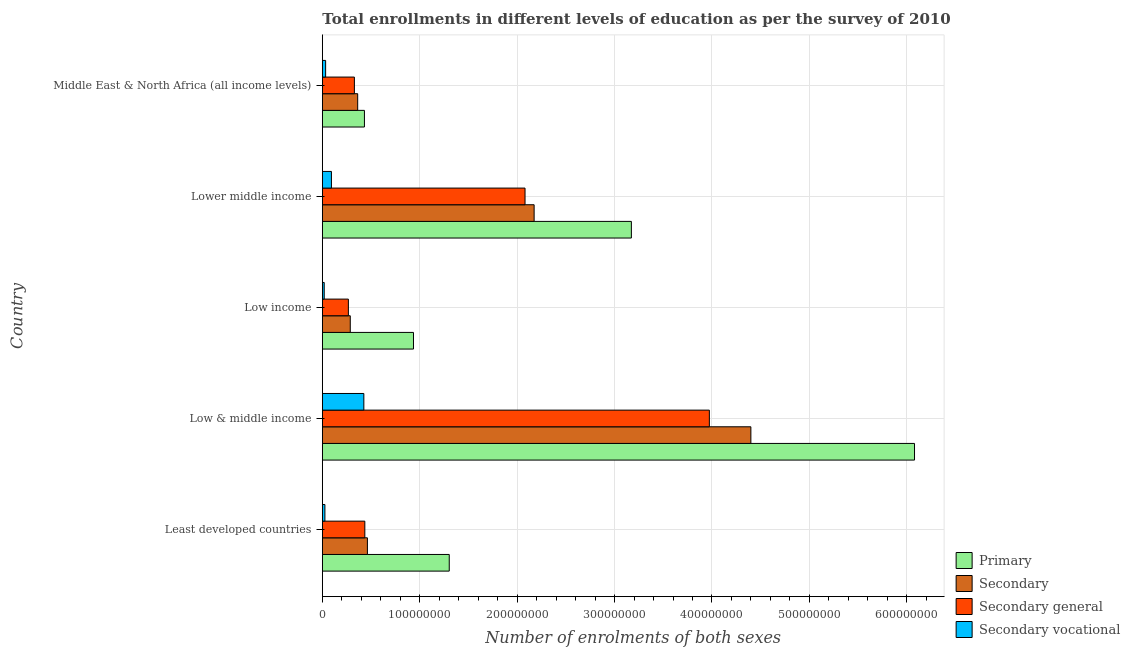Are the number of bars per tick equal to the number of legend labels?
Give a very brief answer. Yes. What is the label of the 5th group of bars from the top?
Make the answer very short. Least developed countries. In how many cases, is the number of bars for a given country not equal to the number of legend labels?
Ensure brevity in your answer.  0. What is the number of enrolments in secondary general education in Low & middle income?
Offer a very short reply. 3.97e+08. Across all countries, what is the maximum number of enrolments in secondary general education?
Provide a succinct answer. 3.97e+08. Across all countries, what is the minimum number of enrolments in primary education?
Offer a terse response. 4.32e+07. In which country was the number of enrolments in primary education minimum?
Your answer should be very brief. Middle East & North Africa (all income levels). What is the total number of enrolments in primary education in the graph?
Make the answer very short. 1.19e+09. What is the difference between the number of enrolments in secondary general education in Low income and that in Lower middle income?
Offer a very short reply. -1.81e+08. What is the difference between the number of enrolments in secondary vocational education in Low & middle income and the number of enrolments in primary education in Least developed countries?
Offer a very short reply. -8.77e+07. What is the average number of enrolments in secondary education per country?
Provide a succinct answer. 1.54e+08. What is the difference between the number of enrolments in secondary general education and number of enrolments in secondary education in Lower middle income?
Your answer should be compact. -9.35e+06. In how many countries, is the number of enrolments in secondary general education greater than 180000000 ?
Make the answer very short. 2. What is the ratio of the number of enrolments in secondary general education in Low & middle income to that in Low income?
Give a very brief answer. 14.86. Is the number of enrolments in secondary general education in Lower middle income less than that in Middle East & North Africa (all income levels)?
Make the answer very short. No. What is the difference between the highest and the second highest number of enrolments in secondary vocational education?
Make the answer very short. 3.33e+07. What is the difference between the highest and the lowest number of enrolments in secondary vocational education?
Provide a short and direct response. 4.07e+07. Is the sum of the number of enrolments in secondary vocational education in Least developed countries and Lower middle income greater than the maximum number of enrolments in secondary general education across all countries?
Give a very brief answer. No. Is it the case that in every country, the sum of the number of enrolments in secondary general education and number of enrolments in primary education is greater than the sum of number of enrolments in secondary education and number of enrolments in secondary vocational education?
Keep it short and to the point. No. What does the 4th bar from the top in Least developed countries represents?
Your answer should be very brief. Primary. What does the 2nd bar from the bottom in Low & middle income represents?
Your answer should be very brief. Secondary. How many bars are there?
Make the answer very short. 20. How many countries are there in the graph?
Offer a terse response. 5. What is the difference between two consecutive major ticks on the X-axis?
Offer a very short reply. 1.00e+08. Does the graph contain grids?
Offer a terse response. Yes. Where does the legend appear in the graph?
Make the answer very short. Bottom right. How are the legend labels stacked?
Your response must be concise. Vertical. What is the title of the graph?
Give a very brief answer. Total enrollments in different levels of education as per the survey of 2010. Does "Fourth 20% of population" appear as one of the legend labels in the graph?
Keep it short and to the point. No. What is the label or title of the X-axis?
Provide a succinct answer. Number of enrolments of both sexes. What is the Number of enrolments of both sexes in Primary in Least developed countries?
Ensure brevity in your answer.  1.30e+08. What is the Number of enrolments of both sexes in Secondary in Least developed countries?
Provide a short and direct response. 4.63e+07. What is the Number of enrolments of both sexes of Secondary general in Least developed countries?
Give a very brief answer. 4.36e+07. What is the Number of enrolments of both sexes in Secondary vocational in Least developed countries?
Provide a short and direct response. 2.65e+06. What is the Number of enrolments of both sexes in Primary in Low & middle income?
Your answer should be very brief. 6.08e+08. What is the Number of enrolments of both sexes of Secondary in Low & middle income?
Offer a very short reply. 4.40e+08. What is the Number of enrolments of both sexes of Secondary general in Low & middle income?
Give a very brief answer. 3.97e+08. What is the Number of enrolments of both sexes in Secondary vocational in Low & middle income?
Your response must be concise. 4.26e+07. What is the Number of enrolments of both sexes of Primary in Low income?
Your response must be concise. 9.36e+07. What is the Number of enrolments of both sexes of Secondary in Low income?
Provide a short and direct response. 2.87e+07. What is the Number of enrolments of both sexes of Secondary general in Low income?
Your answer should be compact. 2.67e+07. What is the Number of enrolments of both sexes in Secondary vocational in Low income?
Your answer should be very brief. 1.94e+06. What is the Number of enrolments of both sexes of Primary in Lower middle income?
Offer a very short reply. 3.17e+08. What is the Number of enrolments of both sexes in Secondary in Lower middle income?
Your response must be concise. 2.17e+08. What is the Number of enrolments of both sexes of Secondary general in Lower middle income?
Your answer should be very brief. 2.08e+08. What is the Number of enrolments of both sexes in Secondary vocational in Lower middle income?
Give a very brief answer. 9.35e+06. What is the Number of enrolments of both sexes of Primary in Middle East & North Africa (all income levels)?
Keep it short and to the point. 4.32e+07. What is the Number of enrolments of both sexes of Secondary in Middle East & North Africa (all income levels)?
Your answer should be very brief. 3.63e+07. What is the Number of enrolments of both sexes in Secondary general in Middle East & North Africa (all income levels)?
Your answer should be very brief. 3.29e+07. What is the Number of enrolments of both sexes in Secondary vocational in Middle East & North Africa (all income levels)?
Offer a terse response. 3.39e+06. Across all countries, what is the maximum Number of enrolments of both sexes in Primary?
Make the answer very short. 6.08e+08. Across all countries, what is the maximum Number of enrolments of both sexes in Secondary?
Your answer should be very brief. 4.40e+08. Across all countries, what is the maximum Number of enrolments of both sexes of Secondary general?
Provide a short and direct response. 3.97e+08. Across all countries, what is the maximum Number of enrolments of both sexes in Secondary vocational?
Your answer should be compact. 4.26e+07. Across all countries, what is the minimum Number of enrolments of both sexes in Primary?
Give a very brief answer. 4.32e+07. Across all countries, what is the minimum Number of enrolments of both sexes in Secondary?
Offer a very short reply. 2.87e+07. Across all countries, what is the minimum Number of enrolments of both sexes of Secondary general?
Make the answer very short. 2.67e+07. Across all countries, what is the minimum Number of enrolments of both sexes in Secondary vocational?
Offer a very short reply. 1.94e+06. What is the total Number of enrolments of both sexes in Primary in the graph?
Offer a terse response. 1.19e+09. What is the total Number of enrolments of both sexes in Secondary in the graph?
Give a very brief answer. 7.69e+08. What is the total Number of enrolments of both sexes of Secondary general in the graph?
Your response must be concise. 7.09e+08. What is the total Number of enrolments of both sexes in Secondary vocational in the graph?
Your answer should be very brief. 5.99e+07. What is the difference between the Number of enrolments of both sexes in Primary in Least developed countries and that in Low & middle income?
Provide a short and direct response. -4.78e+08. What is the difference between the Number of enrolments of both sexes of Secondary in Least developed countries and that in Low & middle income?
Provide a succinct answer. -3.94e+08. What is the difference between the Number of enrolments of both sexes in Secondary general in Least developed countries and that in Low & middle income?
Give a very brief answer. -3.54e+08. What is the difference between the Number of enrolments of both sexes of Secondary vocational in Least developed countries and that in Low & middle income?
Keep it short and to the point. -4.00e+07. What is the difference between the Number of enrolments of both sexes of Primary in Least developed countries and that in Low income?
Keep it short and to the point. 3.67e+07. What is the difference between the Number of enrolments of both sexes in Secondary in Least developed countries and that in Low income?
Your answer should be very brief. 1.76e+07. What is the difference between the Number of enrolments of both sexes of Secondary general in Least developed countries and that in Low income?
Provide a succinct answer. 1.69e+07. What is the difference between the Number of enrolments of both sexes in Secondary vocational in Least developed countries and that in Low income?
Offer a terse response. 7.09e+05. What is the difference between the Number of enrolments of both sexes of Primary in Least developed countries and that in Lower middle income?
Ensure brevity in your answer.  -1.87e+08. What is the difference between the Number of enrolments of both sexes of Secondary in Least developed countries and that in Lower middle income?
Give a very brief answer. -1.71e+08. What is the difference between the Number of enrolments of both sexes of Secondary general in Least developed countries and that in Lower middle income?
Offer a terse response. -1.64e+08. What is the difference between the Number of enrolments of both sexes in Secondary vocational in Least developed countries and that in Lower middle income?
Keep it short and to the point. -6.69e+06. What is the difference between the Number of enrolments of both sexes in Primary in Least developed countries and that in Middle East & North Africa (all income levels)?
Give a very brief answer. 8.71e+07. What is the difference between the Number of enrolments of both sexes of Secondary in Least developed countries and that in Middle East & North Africa (all income levels)?
Your response must be concise. 9.99e+06. What is the difference between the Number of enrolments of both sexes of Secondary general in Least developed countries and that in Middle East & North Africa (all income levels)?
Provide a succinct answer. 1.07e+07. What is the difference between the Number of enrolments of both sexes of Secondary vocational in Least developed countries and that in Middle East & North Africa (all income levels)?
Make the answer very short. -7.37e+05. What is the difference between the Number of enrolments of both sexes in Primary in Low & middle income and that in Low income?
Offer a terse response. 5.14e+08. What is the difference between the Number of enrolments of both sexes of Secondary in Low & middle income and that in Low income?
Your response must be concise. 4.11e+08. What is the difference between the Number of enrolments of both sexes in Secondary general in Low & middle income and that in Low income?
Offer a terse response. 3.71e+08. What is the difference between the Number of enrolments of both sexes of Secondary vocational in Low & middle income and that in Low income?
Give a very brief answer. 4.07e+07. What is the difference between the Number of enrolments of both sexes in Primary in Low & middle income and that in Lower middle income?
Provide a succinct answer. 2.91e+08. What is the difference between the Number of enrolments of both sexes of Secondary in Low & middle income and that in Lower middle income?
Offer a very short reply. 2.22e+08. What is the difference between the Number of enrolments of both sexes in Secondary general in Low & middle income and that in Lower middle income?
Keep it short and to the point. 1.89e+08. What is the difference between the Number of enrolments of both sexes of Secondary vocational in Low & middle income and that in Lower middle income?
Offer a very short reply. 3.33e+07. What is the difference between the Number of enrolments of both sexes in Primary in Low & middle income and that in Middle East & North Africa (all income levels)?
Your answer should be very brief. 5.65e+08. What is the difference between the Number of enrolments of both sexes of Secondary in Low & middle income and that in Middle East & North Africa (all income levels)?
Give a very brief answer. 4.04e+08. What is the difference between the Number of enrolments of both sexes of Secondary general in Low & middle income and that in Middle East & North Africa (all income levels)?
Your answer should be very brief. 3.64e+08. What is the difference between the Number of enrolments of both sexes of Secondary vocational in Low & middle income and that in Middle East & North Africa (all income levels)?
Offer a terse response. 3.92e+07. What is the difference between the Number of enrolments of both sexes of Primary in Low income and that in Lower middle income?
Provide a succinct answer. -2.24e+08. What is the difference between the Number of enrolments of both sexes of Secondary in Low income and that in Lower middle income?
Make the answer very short. -1.89e+08. What is the difference between the Number of enrolments of both sexes of Secondary general in Low income and that in Lower middle income?
Your answer should be very brief. -1.81e+08. What is the difference between the Number of enrolments of both sexes of Secondary vocational in Low income and that in Lower middle income?
Your response must be concise. -7.40e+06. What is the difference between the Number of enrolments of both sexes of Primary in Low income and that in Middle East & North Africa (all income levels)?
Offer a terse response. 5.04e+07. What is the difference between the Number of enrolments of both sexes of Secondary in Low income and that in Middle East & North Africa (all income levels)?
Provide a short and direct response. -7.61e+06. What is the difference between the Number of enrolments of both sexes in Secondary general in Low income and that in Middle East & North Africa (all income levels)?
Keep it short and to the point. -6.16e+06. What is the difference between the Number of enrolments of both sexes in Secondary vocational in Low income and that in Middle East & North Africa (all income levels)?
Give a very brief answer. -1.45e+06. What is the difference between the Number of enrolments of both sexes of Primary in Lower middle income and that in Middle East & North Africa (all income levels)?
Provide a short and direct response. 2.74e+08. What is the difference between the Number of enrolments of both sexes in Secondary in Lower middle income and that in Middle East & North Africa (all income levels)?
Make the answer very short. 1.81e+08. What is the difference between the Number of enrolments of both sexes of Secondary general in Lower middle income and that in Middle East & North Africa (all income levels)?
Offer a terse response. 1.75e+08. What is the difference between the Number of enrolments of both sexes of Secondary vocational in Lower middle income and that in Middle East & North Africa (all income levels)?
Keep it short and to the point. 5.96e+06. What is the difference between the Number of enrolments of both sexes in Primary in Least developed countries and the Number of enrolments of both sexes in Secondary in Low & middle income?
Offer a very short reply. -3.10e+08. What is the difference between the Number of enrolments of both sexes of Primary in Least developed countries and the Number of enrolments of both sexes of Secondary general in Low & middle income?
Make the answer very short. -2.67e+08. What is the difference between the Number of enrolments of both sexes of Primary in Least developed countries and the Number of enrolments of both sexes of Secondary vocational in Low & middle income?
Your response must be concise. 8.77e+07. What is the difference between the Number of enrolments of both sexes of Secondary in Least developed countries and the Number of enrolments of both sexes of Secondary general in Low & middle income?
Keep it short and to the point. -3.51e+08. What is the difference between the Number of enrolments of both sexes of Secondary in Least developed countries and the Number of enrolments of both sexes of Secondary vocational in Low & middle income?
Provide a succinct answer. 3.66e+06. What is the difference between the Number of enrolments of both sexes in Secondary general in Least developed countries and the Number of enrolments of both sexes in Secondary vocational in Low & middle income?
Provide a succinct answer. 1.01e+06. What is the difference between the Number of enrolments of both sexes of Primary in Least developed countries and the Number of enrolments of both sexes of Secondary in Low income?
Ensure brevity in your answer.  1.02e+08. What is the difference between the Number of enrolments of both sexes in Primary in Least developed countries and the Number of enrolments of both sexes in Secondary general in Low income?
Your response must be concise. 1.04e+08. What is the difference between the Number of enrolments of both sexes in Primary in Least developed countries and the Number of enrolments of both sexes in Secondary vocational in Low income?
Ensure brevity in your answer.  1.28e+08. What is the difference between the Number of enrolments of both sexes in Secondary in Least developed countries and the Number of enrolments of both sexes in Secondary general in Low income?
Your answer should be compact. 1.95e+07. What is the difference between the Number of enrolments of both sexes in Secondary in Least developed countries and the Number of enrolments of both sexes in Secondary vocational in Low income?
Your answer should be compact. 4.43e+07. What is the difference between the Number of enrolments of both sexes in Secondary general in Least developed countries and the Number of enrolments of both sexes in Secondary vocational in Low income?
Ensure brevity in your answer.  4.17e+07. What is the difference between the Number of enrolments of both sexes of Primary in Least developed countries and the Number of enrolments of both sexes of Secondary in Lower middle income?
Your answer should be very brief. -8.71e+07. What is the difference between the Number of enrolments of both sexes in Primary in Least developed countries and the Number of enrolments of both sexes in Secondary general in Lower middle income?
Offer a very short reply. -7.78e+07. What is the difference between the Number of enrolments of both sexes of Primary in Least developed countries and the Number of enrolments of both sexes of Secondary vocational in Lower middle income?
Ensure brevity in your answer.  1.21e+08. What is the difference between the Number of enrolments of both sexes in Secondary in Least developed countries and the Number of enrolments of both sexes in Secondary general in Lower middle income?
Your answer should be very brief. -1.62e+08. What is the difference between the Number of enrolments of both sexes of Secondary in Least developed countries and the Number of enrolments of both sexes of Secondary vocational in Lower middle income?
Offer a very short reply. 3.69e+07. What is the difference between the Number of enrolments of both sexes of Secondary general in Least developed countries and the Number of enrolments of both sexes of Secondary vocational in Lower middle income?
Offer a terse response. 3.43e+07. What is the difference between the Number of enrolments of both sexes of Primary in Least developed countries and the Number of enrolments of both sexes of Secondary in Middle East & North Africa (all income levels)?
Your response must be concise. 9.40e+07. What is the difference between the Number of enrolments of both sexes in Primary in Least developed countries and the Number of enrolments of both sexes in Secondary general in Middle East & North Africa (all income levels)?
Your response must be concise. 9.74e+07. What is the difference between the Number of enrolments of both sexes in Primary in Least developed countries and the Number of enrolments of both sexes in Secondary vocational in Middle East & North Africa (all income levels)?
Your response must be concise. 1.27e+08. What is the difference between the Number of enrolments of both sexes of Secondary in Least developed countries and the Number of enrolments of both sexes of Secondary general in Middle East & North Africa (all income levels)?
Make the answer very short. 1.34e+07. What is the difference between the Number of enrolments of both sexes in Secondary in Least developed countries and the Number of enrolments of both sexes in Secondary vocational in Middle East & North Africa (all income levels)?
Your answer should be very brief. 4.29e+07. What is the difference between the Number of enrolments of both sexes of Secondary general in Least developed countries and the Number of enrolments of both sexes of Secondary vocational in Middle East & North Africa (all income levels)?
Provide a short and direct response. 4.02e+07. What is the difference between the Number of enrolments of both sexes of Primary in Low & middle income and the Number of enrolments of both sexes of Secondary in Low income?
Offer a terse response. 5.79e+08. What is the difference between the Number of enrolments of both sexes in Primary in Low & middle income and the Number of enrolments of both sexes in Secondary general in Low income?
Make the answer very short. 5.81e+08. What is the difference between the Number of enrolments of both sexes of Primary in Low & middle income and the Number of enrolments of both sexes of Secondary vocational in Low income?
Keep it short and to the point. 6.06e+08. What is the difference between the Number of enrolments of both sexes of Secondary in Low & middle income and the Number of enrolments of both sexes of Secondary general in Low income?
Offer a very short reply. 4.13e+08. What is the difference between the Number of enrolments of both sexes of Secondary in Low & middle income and the Number of enrolments of both sexes of Secondary vocational in Low income?
Provide a succinct answer. 4.38e+08. What is the difference between the Number of enrolments of both sexes of Secondary general in Low & middle income and the Number of enrolments of both sexes of Secondary vocational in Low income?
Your answer should be compact. 3.95e+08. What is the difference between the Number of enrolments of both sexes in Primary in Low & middle income and the Number of enrolments of both sexes in Secondary in Lower middle income?
Provide a short and direct response. 3.90e+08. What is the difference between the Number of enrolments of both sexes of Primary in Low & middle income and the Number of enrolments of both sexes of Secondary general in Lower middle income?
Your answer should be very brief. 4.00e+08. What is the difference between the Number of enrolments of both sexes in Primary in Low & middle income and the Number of enrolments of both sexes in Secondary vocational in Lower middle income?
Offer a very short reply. 5.99e+08. What is the difference between the Number of enrolments of both sexes of Secondary in Low & middle income and the Number of enrolments of both sexes of Secondary general in Lower middle income?
Your response must be concise. 2.32e+08. What is the difference between the Number of enrolments of both sexes of Secondary in Low & middle income and the Number of enrolments of both sexes of Secondary vocational in Lower middle income?
Your answer should be very brief. 4.31e+08. What is the difference between the Number of enrolments of both sexes of Secondary general in Low & middle income and the Number of enrolments of both sexes of Secondary vocational in Lower middle income?
Your response must be concise. 3.88e+08. What is the difference between the Number of enrolments of both sexes of Primary in Low & middle income and the Number of enrolments of both sexes of Secondary in Middle East & North Africa (all income levels)?
Provide a succinct answer. 5.72e+08. What is the difference between the Number of enrolments of both sexes in Primary in Low & middle income and the Number of enrolments of both sexes in Secondary general in Middle East & North Africa (all income levels)?
Provide a succinct answer. 5.75e+08. What is the difference between the Number of enrolments of both sexes of Primary in Low & middle income and the Number of enrolments of both sexes of Secondary vocational in Middle East & North Africa (all income levels)?
Offer a terse response. 6.05e+08. What is the difference between the Number of enrolments of both sexes in Secondary in Low & middle income and the Number of enrolments of both sexes in Secondary general in Middle East & North Africa (all income levels)?
Provide a succinct answer. 4.07e+08. What is the difference between the Number of enrolments of both sexes in Secondary in Low & middle income and the Number of enrolments of both sexes in Secondary vocational in Middle East & North Africa (all income levels)?
Ensure brevity in your answer.  4.37e+08. What is the difference between the Number of enrolments of both sexes of Secondary general in Low & middle income and the Number of enrolments of both sexes of Secondary vocational in Middle East & North Africa (all income levels)?
Your answer should be compact. 3.94e+08. What is the difference between the Number of enrolments of both sexes in Primary in Low income and the Number of enrolments of both sexes in Secondary in Lower middle income?
Provide a succinct answer. -1.24e+08. What is the difference between the Number of enrolments of both sexes of Primary in Low income and the Number of enrolments of both sexes of Secondary general in Lower middle income?
Your answer should be very brief. -1.15e+08. What is the difference between the Number of enrolments of both sexes in Primary in Low income and the Number of enrolments of both sexes in Secondary vocational in Lower middle income?
Provide a short and direct response. 8.42e+07. What is the difference between the Number of enrolments of both sexes of Secondary in Low income and the Number of enrolments of both sexes of Secondary general in Lower middle income?
Your answer should be very brief. -1.79e+08. What is the difference between the Number of enrolments of both sexes of Secondary in Low income and the Number of enrolments of both sexes of Secondary vocational in Lower middle income?
Your answer should be compact. 1.93e+07. What is the difference between the Number of enrolments of both sexes of Secondary general in Low income and the Number of enrolments of both sexes of Secondary vocational in Lower middle income?
Make the answer very short. 1.74e+07. What is the difference between the Number of enrolments of both sexes of Primary in Low income and the Number of enrolments of both sexes of Secondary in Middle East & North Africa (all income levels)?
Offer a terse response. 5.73e+07. What is the difference between the Number of enrolments of both sexes of Primary in Low income and the Number of enrolments of both sexes of Secondary general in Middle East & North Africa (all income levels)?
Provide a succinct answer. 6.07e+07. What is the difference between the Number of enrolments of both sexes in Primary in Low income and the Number of enrolments of both sexes in Secondary vocational in Middle East & North Africa (all income levels)?
Provide a succinct answer. 9.02e+07. What is the difference between the Number of enrolments of both sexes of Secondary in Low income and the Number of enrolments of both sexes of Secondary general in Middle East & North Africa (all income levels)?
Offer a very short reply. -4.22e+06. What is the difference between the Number of enrolments of both sexes in Secondary in Low income and the Number of enrolments of both sexes in Secondary vocational in Middle East & North Africa (all income levels)?
Provide a succinct answer. 2.53e+07. What is the difference between the Number of enrolments of both sexes in Secondary general in Low income and the Number of enrolments of both sexes in Secondary vocational in Middle East & North Africa (all income levels)?
Your answer should be compact. 2.34e+07. What is the difference between the Number of enrolments of both sexes of Primary in Lower middle income and the Number of enrolments of both sexes of Secondary in Middle East & North Africa (all income levels)?
Your answer should be compact. 2.81e+08. What is the difference between the Number of enrolments of both sexes of Primary in Lower middle income and the Number of enrolments of both sexes of Secondary general in Middle East & North Africa (all income levels)?
Your response must be concise. 2.84e+08. What is the difference between the Number of enrolments of both sexes of Primary in Lower middle income and the Number of enrolments of both sexes of Secondary vocational in Middle East & North Africa (all income levels)?
Provide a succinct answer. 3.14e+08. What is the difference between the Number of enrolments of both sexes of Secondary in Lower middle income and the Number of enrolments of both sexes of Secondary general in Middle East & North Africa (all income levels)?
Provide a succinct answer. 1.85e+08. What is the difference between the Number of enrolments of both sexes in Secondary in Lower middle income and the Number of enrolments of both sexes in Secondary vocational in Middle East & North Africa (all income levels)?
Provide a short and direct response. 2.14e+08. What is the difference between the Number of enrolments of both sexes of Secondary general in Lower middle income and the Number of enrolments of both sexes of Secondary vocational in Middle East & North Africa (all income levels)?
Keep it short and to the point. 2.05e+08. What is the average Number of enrolments of both sexes in Primary per country?
Your response must be concise. 2.38e+08. What is the average Number of enrolments of both sexes of Secondary per country?
Provide a succinct answer. 1.54e+08. What is the average Number of enrolments of both sexes of Secondary general per country?
Ensure brevity in your answer.  1.42e+08. What is the average Number of enrolments of both sexes of Secondary vocational per country?
Keep it short and to the point. 1.20e+07. What is the difference between the Number of enrolments of both sexes of Primary and Number of enrolments of both sexes of Secondary in Least developed countries?
Offer a terse response. 8.40e+07. What is the difference between the Number of enrolments of both sexes of Primary and Number of enrolments of both sexes of Secondary general in Least developed countries?
Your answer should be compact. 8.67e+07. What is the difference between the Number of enrolments of both sexes in Primary and Number of enrolments of both sexes in Secondary vocational in Least developed countries?
Provide a short and direct response. 1.28e+08. What is the difference between the Number of enrolments of both sexes in Secondary and Number of enrolments of both sexes in Secondary general in Least developed countries?
Offer a very short reply. 2.65e+06. What is the difference between the Number of enrolments of both sexes in Secondary and Number of enrolments of both sexes in Secondary vocational in Least developed countries?
Your response must be concise. 4.36e+07. What is the difference between the Number of enrolments of both sexes of Secondary general and Number of enrolments of both sexes of Secondary vocational in Least developed countries?
Your response must be concise. 4.10e+07. What is the difference between the Number of enrolments of both sexes in Primary and Number of enrolments of both sexes in Secondary in Low & middle income?
Make the answer very short. 1.68e+08. What is the difference between the Number of enrolments of both sexes of Primary and Number of enrolments of both sexes of Secondary general in Low & middle income?
Provide a short and direct response. 2.11e+08. What is the difference between the Number of enrolments of both sexes of Primary and Number of enrolments of both sexes of Secondary vocational in Low & middle income?
Your answer should be compact. 5.65e+08. What is the difference between the Number of enrolments of both sexes in Secondary and Number of enrolments of both sexes in Secondary general in Low & middle income?
Your response must be concise. 4.26e+07. What is the difference between the Number of enrolments of both sexes of Secondary and Number of enrolments of both sexes of Secondary vocational in Low & middle income?
Give a very brief answer. 3.97e+08. What is the difference between the Number of enrolments of both sexes in Secondary general and Number of enrolments of both sexes in Secondary vocational in Low & middle income?
Offer a terse response. 3.55e+08. What is the difference between the Number of enrolments of both sexes of Primary and Number of enrolments of both sexes of Secondary in Low income?
Offer a terse response. 6.49e+07. What is the difference between the Number of enrolments of both sexes in Primary and Number of enrolments of both sexes in Secondary general in Low income?
Your response must be concise. 6.68e+07. What is the difference between the Number of enrolments of both sexes of Primary and Number of enrolments of both sexes of Secondary vocational in Low income?
Provide a succinct answer. 9.16e+07. What is the difference between the Number of enrolments of both sexes of Secondary and Number of enrolments of both sexes of Secondary general in Low income?
Your answer should be very brief. 1.94e+06. What is the difference between the Number of enrolments of both sexes of Secondary and Number of enrolments of both sexes of Secondary vocational in Low income?
Provide a succinct answer. 2.67e+07. What is the difference between the Number of enrolments of both sexes of Secondary general and Number of enrolments of both sexes of Secondary vocational in Low income?
Provide a short and direct response. 2.48e+07. What is the difference between the Number of enrolments of both sexes of Primary and Number of enrolments of both sexes of Secondary in Lower middle income?
Keep it short and to the point. 9.98e+07. What is the difference between the Number of enrolments of both sexes in Primary and Number of enrolments of both sexes in Secondary general in Lower middle income?
Offer a terse response. 1.09e+08. What is the difference between the Number of enrolments of both sexes in Primary and Number of enrolments of both sexes in Secondary vocational in Lower middle income?
Make the answer very short. 3.08e+08. What is the difference between the Number of enrolments of both sexes in Secondary and Number of enrolments of both sexes in Secondary general in Lower middle income?
Offer a very short reply. 9.35e+06. What is the difference between the Number of enrolments of both sexes of Secondary and Number of enrolments of both sexes of Secondary vocational in Lower middle income?
Ensure brevity in your answer.  2.08e+08. What is the difference between the Number of enrolments of both sexes of Secondary general and Number of enrolments of both sexes of Secondary vocational in Lower middle income?
Offer a terse response. 1.99e+08. What is the difference between the Number of enrolments of both sexes in Primary and Number of enrolments of both sexes in Secondary in Middle East & North Africa (all income levels)?
Keep it short and to the point. 6.93e+06. What is the difference between the Number of enrolments of both sexes in Primary and Number of enrolments of both sexes in Secondary general in Middle East & North Africa (all income levels)?
Your response must be concise. 1.03e+07. What is the difference between the Number of enrolments of both sexes of Primary and Number of enrolments of both sexes of Secondary vocational in Middle East & North Africa (all income levels)?
Your answer should be compact. 3.98e+07. What is the difference between the Number of enrolments of both sexes in Secondary and Number of enrolments of both sexes in Secondary general in Middle East & North Africa (all income levels)?
Offer a very short reply. 3.39e+06. What is the difference between the Number of enrolments of both sexes of Secondary and Number of enrolments of both sexes of Secondary vocational in Middle East & North Africa (all income levels)?
Give a very brief answer. 3.29e+07. What is the difference between the Number of enrolments of both sexes in Secondary general and Number of enrolments of both sexes in Secondary vocational in Middle East & North Africa (all income levels)?
Make the answer very short. 2.95e+07. What is the ratio of the Number of enrolments of both sexes in Primary in Least developed countries to that in Low & middle income?
Provide a short and direct response. 0.21. What is the ratio of the Number of enrolments of both sexes in Secondary in Least developed countries to that in Low & middle income?
Your answer should be compact. 0.11. What is the ratio of the Number of enrolments of both sexes of Secondary general in Least developed countries to that in Low & middle income?
Make the answer very short. 0.11. What is the ratio of the Number of enrolments of both sexes in Secondary vocational in Least developed countries to that in Low & middle income?
Ensure brevity in your answer.  0.06. What is the ratio of the Number of enrolments of both sexes of Primary in Least developed countries to that in Low income?
Give a very brief answer. 1.39. What is the ratio of the Number of enrolments of both sexes of Secondary in Least developed countries to that in Low income?
Your answer should be compact. 1.61. What is the ratio of the Number of enrolments of both sexes of Secondary general in Least developed countries to that in Low income?
Provide a succinct answer. 1.63. What is the ratio of the Number of enrolments of both sexes in Secondary vocational in Least developed countries to that in Low income?
Your answer should be very brief. 1.36. What is the ratio of the Number of enrolments of both sexes in Primary in Least developed countries to that in Lower middle income?
Your answer should be compact. 0.41. What is the ratio of the Number of enrolments of both sexes in Secondary in Least developed countries to that in Lower middle income?
Your response must be concise. 0.21. What is the ratio of the Number of enrolments of both sexes of Secondary general in Least developed countries to that in Lower middle income?
Offer a very short reply. 0.21. What is the ratio of the Number of enrolments of both sexes of Secondary vocational in Least developed countries to that in Lower middle income?
Your answer should be compact. 0.28. What is the ratio of the Number of enrolments of both sexes of Primary in Least developed countries to that in Middle East & North Africa (all income levels)?
Offer a terse response. 3.01. What is the ratio of the Number of enrolments of both sexes in Secondary in Least developed countries to that in Middle East & North Africa (all income levels)?
Give a very brief answer. 1.28. What is the ratio of the Number of enrolments of both sexes in Secondary general in Least developed countries to that in Middle East & North Africa (all income levels)?
Your answer should be compact. 1.33. What is the ratio of the Number of enrolments of both sexes in Secondary vocational in Least developed countries to that in Middle East & North Africa (all income levels)?
Offer a terse response. 0.78. What is the ratio of the Number of enrolments of both sexes of Primary in Low & middle income to that in Low income?
Keep it short and to the point. 6.5. What is the ratio of the Number of enrolments of both sexes in Secondary in Low & middle income to that in Low income?
Your answer should be very brief. 15.34. What is the ratio of the Number of enrolments of both sexes in Secondary general in Low & middle income to that in Low income?
Keep it short and to the point. 14.86. What is the ratio of the Number of enrolments of both sexes in Secondary vocational in Low & middle income to that in Low income?
Provide a succinct answer. 21.95. What is the ratio of the Number of enrolments of both sexes of Primary in Low & middle income to that in Lower middle income?
Your answer should be very brief. 1.92. What is the ratio of the Number of enrolments of both sexes in Secondary in Low & middle income to that in Lower middle income?
Your response must be concise. 2.02. What is the ratio of the Number of enrolments of both sexes in Secondary general in Low & middle income to that in Lower middle income?
Offer a terse response. 1.91. What is the ratio of the Number of enrolments of both sexes of Secondary vocational in Low & middle income to that in Lower middle income?
Give a very brief answer. 4.56. What is the ratio of the Number of enrolments of both sexes of Primary in Low & middle income to that in Middle East & North Africa (all income levels)?
Offer a very short reply. 14.07. What is the ratio of the Number of enrolments of both sexes of Secondary in Low & middle income to that in Middle East & North Africa (all income levels)?
Provide a short and direct response. 12.12. What is the ratio of the Number of enrolments of both sexes in Secondary general in Low & middle income to that in Middle East & North Africa (all income levels)?
Give a very brief answer. 12.07. What is the ratio of the Number of enrolments of both sexes of Secondary vocational in Low & middle income to that in Middle East & North Africa (all income levels)?
Provide a succinct answer. 12.58. What is the ratio of the Number of enrolments of both sexes in Primary in Low income to that in Lower middle income?
Ensure brevity in your answer.  0.29. What is the ratio of the Number of enrolments of both sexes in Secondary in Low income to that in Lower middle income?
Provide a short and direct response. 0.13. What is the ratio of the Number of enrolments of both sexes in Secondary general in Low income to that in Lower middle income?
Keep it short and to the point. 0.13. What is the ratio of the Number of enrolments of both sexes in Secondary vocational in Low income to that in Lower middle income?
Make the answer very short. 0.21. What is the ratio of the Number of enrolments of both sexes in Primary in Low income to that in Middle East & North Africa (all income levels)?
Provide a short and direct response. 2.17. What is the ratio of the Number of enrolments of both sexes in Secondary in Low income to that in Middle East & North Africa (all income levels)?
Keep it short and to the point. 0.79. What is the ratio of the Number of enrolments of both sexes of Secondary general in Low income to that in Middle East & North Africa (all income levels)?
Your response must be concise. 0.81. What is the ratio of the Number of enrolments of both sexes of Secondary vocational in Low income to that in Middle East & North Africa (all income levels)?
Your response must be concise. 0.57. What is the ratio of the Number of enrolments of both sexes of Primary in Lower middle income to that in Middle East & North Africa (all income levels)?
Your answer should be very brief. 7.34. What is the ratio of the Number of enrolments of both sexes in Secondary in Lower middle income to that in Middle East & North Africa (all income levels)?
Your answer should be very brief. 5.99. What is the ratio of the Number of enrolments of both sexes of Secondary general in Lower middle income to that in Middle East & North Africa (all income levels)?
Ensure brevity in your answer.  6.32. What is the ratio of the Number of enrolments of both sexes of Secondary vocational in Lower middle income to that in Middle East & North Africa (all income levels)?
Give a very brief answer. 2.76. What is the difference between the highest and the second highest Number of enrolments of both sexes in Primary?
Provide a succinct answer. 2.91e+08. What is the difference between the highest and the second highest Number of enrolments of both sexes of Secondary?
Keep it short and to the point. 2.22e+08. What is the difference between the highest and the second highest Number of enrolments of both sexes in Secondary general?
Make the answer very short. 1.89e+08. What is the difference between the highest and the second highest Number of enrolments of both sexes in Secondary vocational?
Provide a short and direct response. 3.33e+07. What is the difference between the highest and the lowest Number of enrolments of both sexes in Primary?
Offer a terse response. 5.65e+08. What is the difference between the highest and the lowest Number of enrolments of both sexes in Secondary?
Provide a succinct answer. 4.11e+08. What is the difference between the highest and the lowest Number of enrolments of both sexes of Secondary general?
Provide a short and direct response. 3.71e+08. What is the difference between the highest and the lowest Number of enrolments of both sexes in Secondary vocational?
Ensure brevity in your answer.  4.07e+07. 